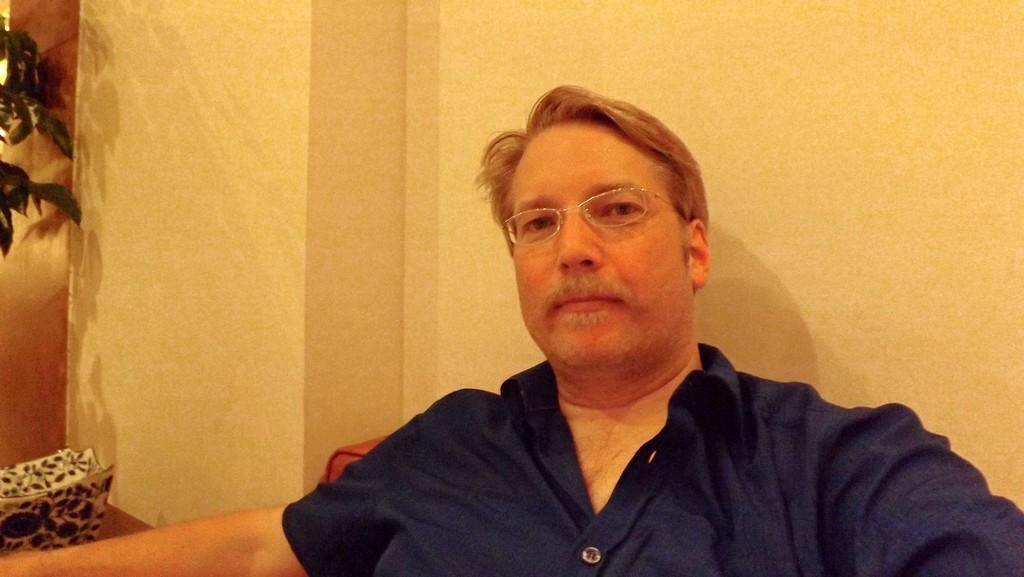Who is the main subject in the image? There is a man in the image. Where is the man positioned in the image? The man is in the front of the image. What is the man wearing in the image? The man is wearing a blue dress and specs. What can be seen on the left side of the image? There is a plant and a white-colored thing on the left side of the image. How many accounts does the man have in the image? There is no mention of any accounts in the image, so it cannot be determined. Are there any dogs present in the image? There are no dogs visible in the image. 